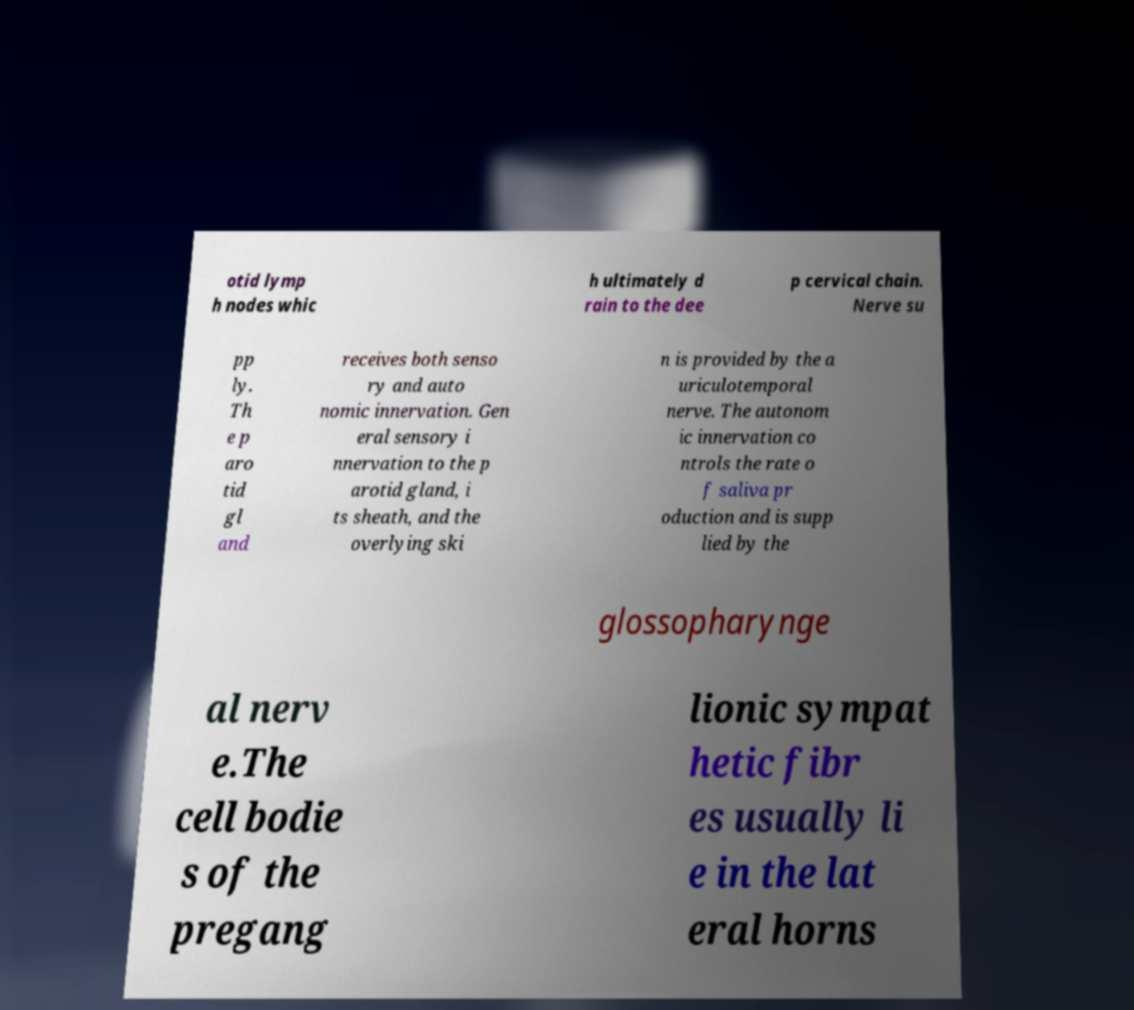Can you accurately transcribe the text from the provided image for me? otid lymp h nodes whic h ultimately d rain to the dee p cervical chain. Nerve su pp ly. Th e p aro tid gl and receives both senso ry and auto nomic innervation. Gen eral sensory i nnervation to the p arotid gland, i ts sheath, and the overlying ski n is provided by the a uriculotemporal nerve. The autonom ic innervation co ntrols the rate o f saliva pr oduction and is supp lied by the glossopharynge al nerv e.The cell bodie s of the pregang lionic sympat hetic fibr es usually li e in the lat eral horns 